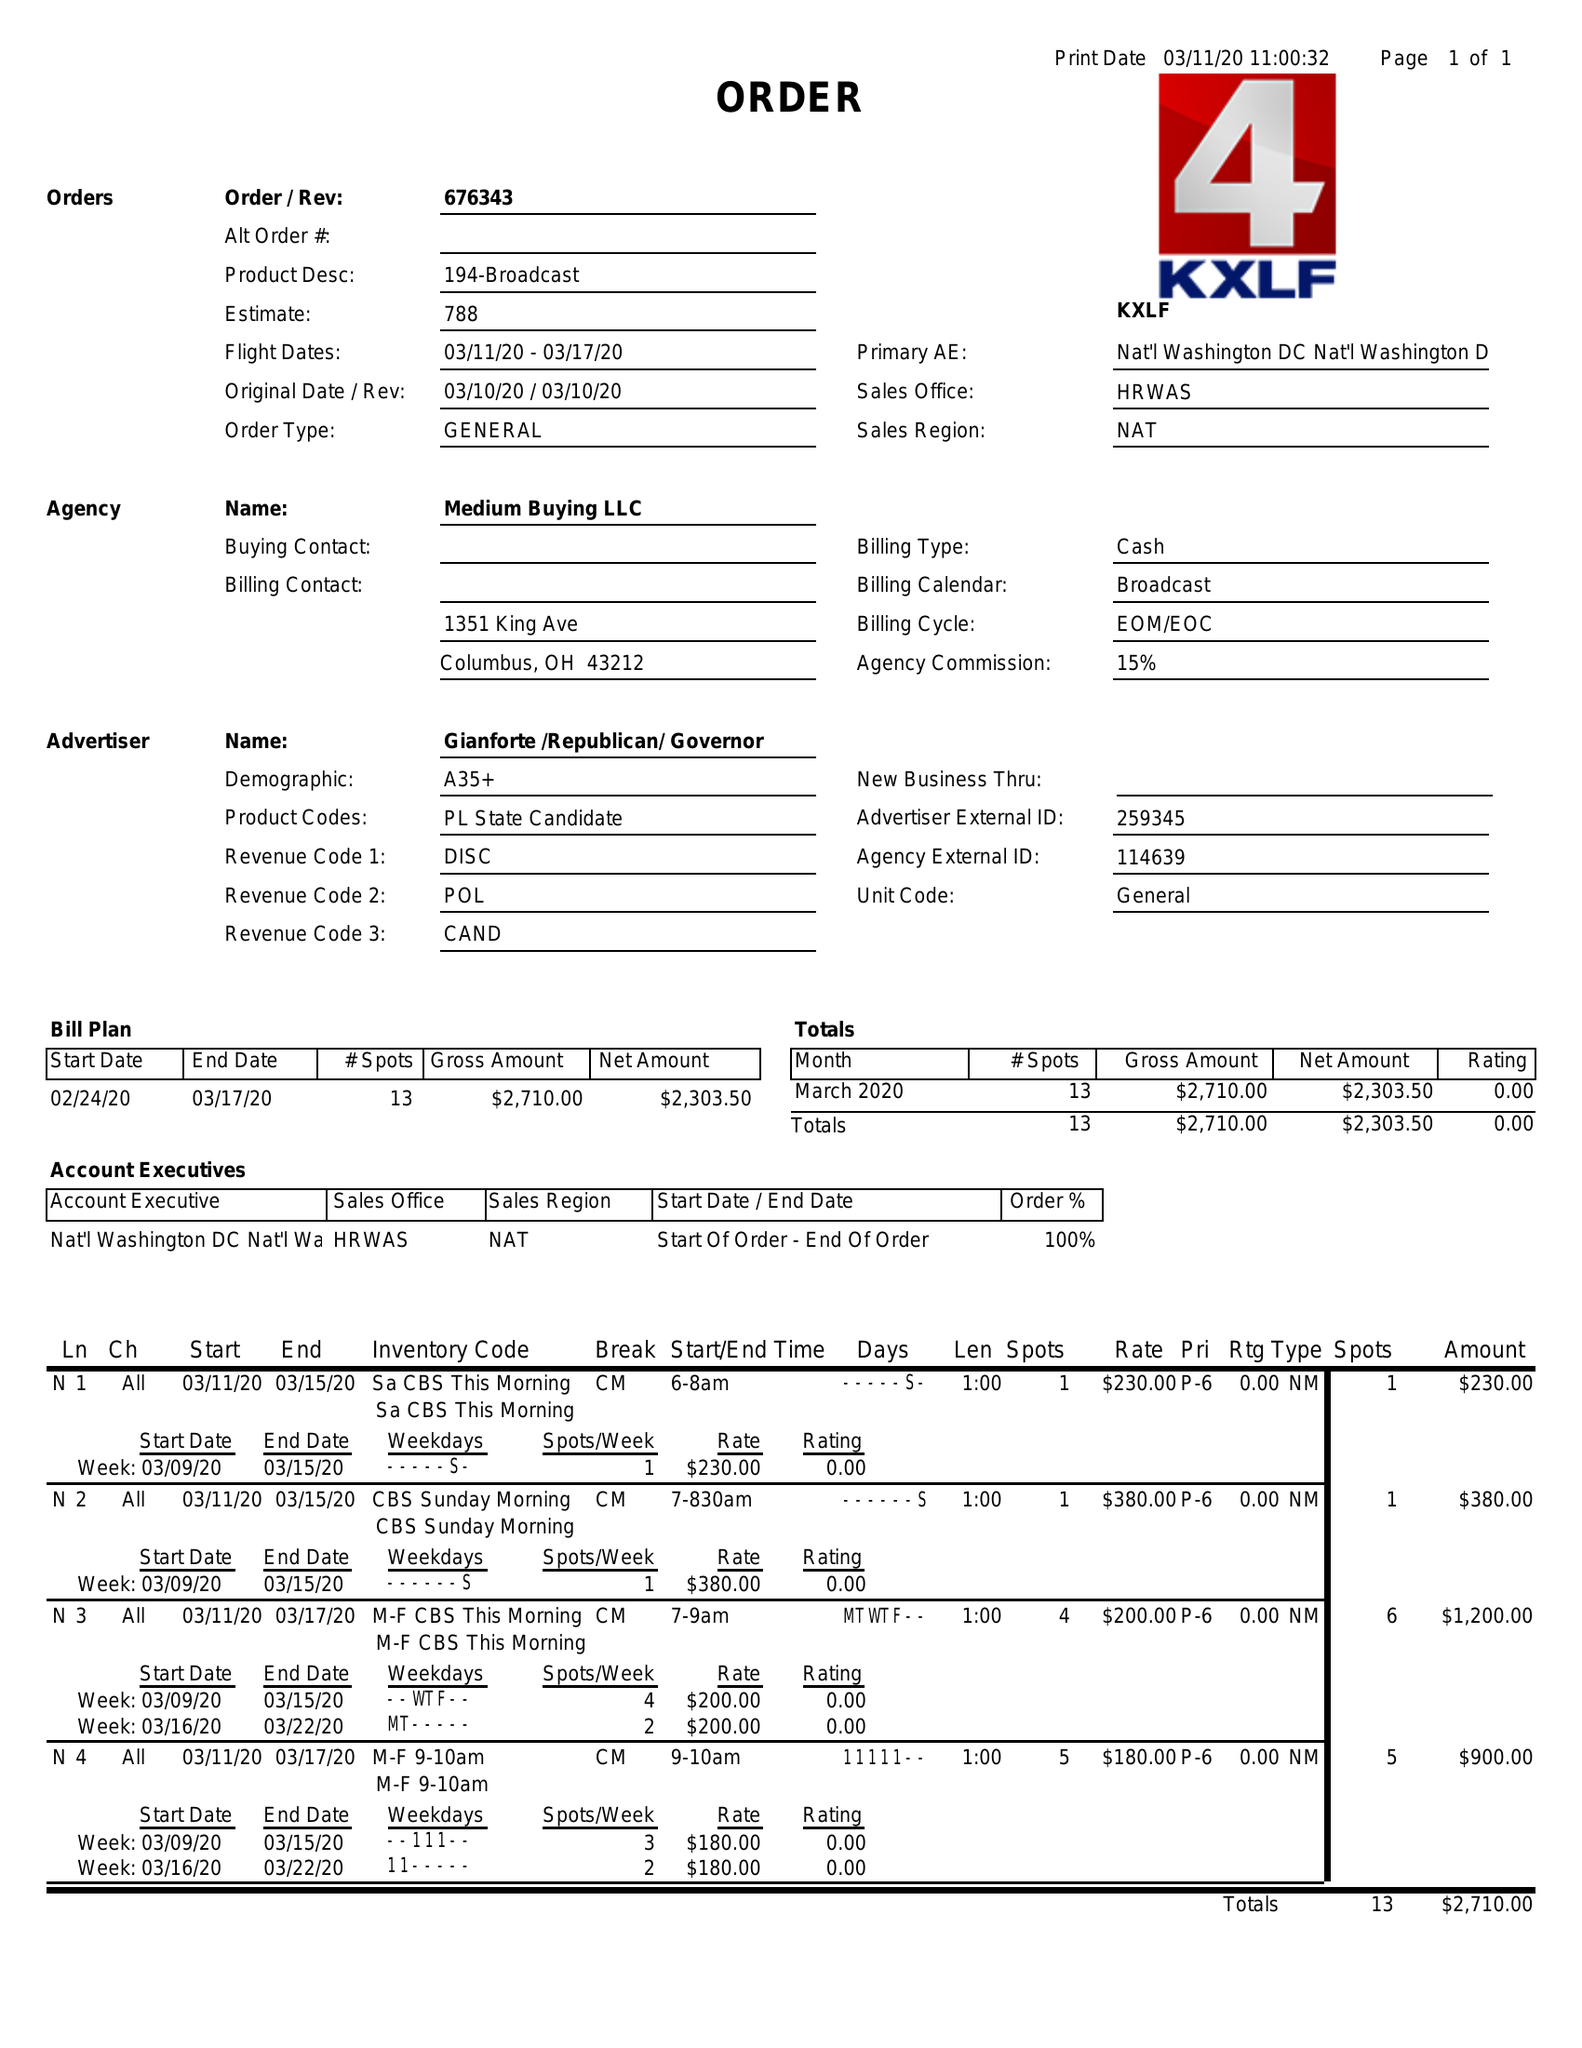What is the value for the advertiser?
Answer the question using a single word or phrase. GIANFORTE/REPUBLICAN/GOVERNOR 